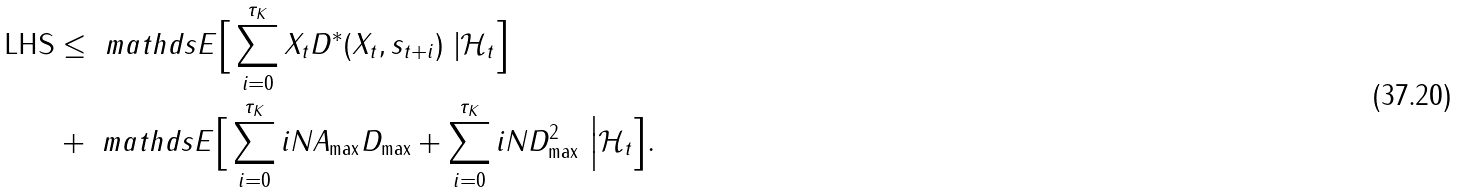Convert formula to latex. <formula><loc_0><loc_0><loc_500><loc_500>\text {LHS} & \leq \ m a t h d s { E } \Big [ \sum _ { i = 0 } ^ { \tau _ { K } } X _ { t } D ^ { * } ( X _ { t } , s _ { t + i } ) \ | \mathcal { H } _ { t } \Big ] \\ & + \ m a t h d s { E } \Big [ \sum _ { i = 0 } ^ { \tau _ { K } } i N A _ { \max } D _ { \max } + \sum _ { i = 0 } ^ { \tau _ { K } } i N D _ { \max } ^ { 2 } \ \Big | \mathcal { H } _ { t } \Big ] .</formula> 